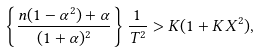<formula> <loc_0><loc_0><loc_500><loc_500>\left \{ \frac { n ( 1 - \alpha ^ { 2 } ) + \alpha } { ( 1 + \alpha ) ^ { 2 } } \right \} \frac { 1 } { T ^ { 2 } } > K ( 1 + K X ^ { 2 } ) ,</formula> 